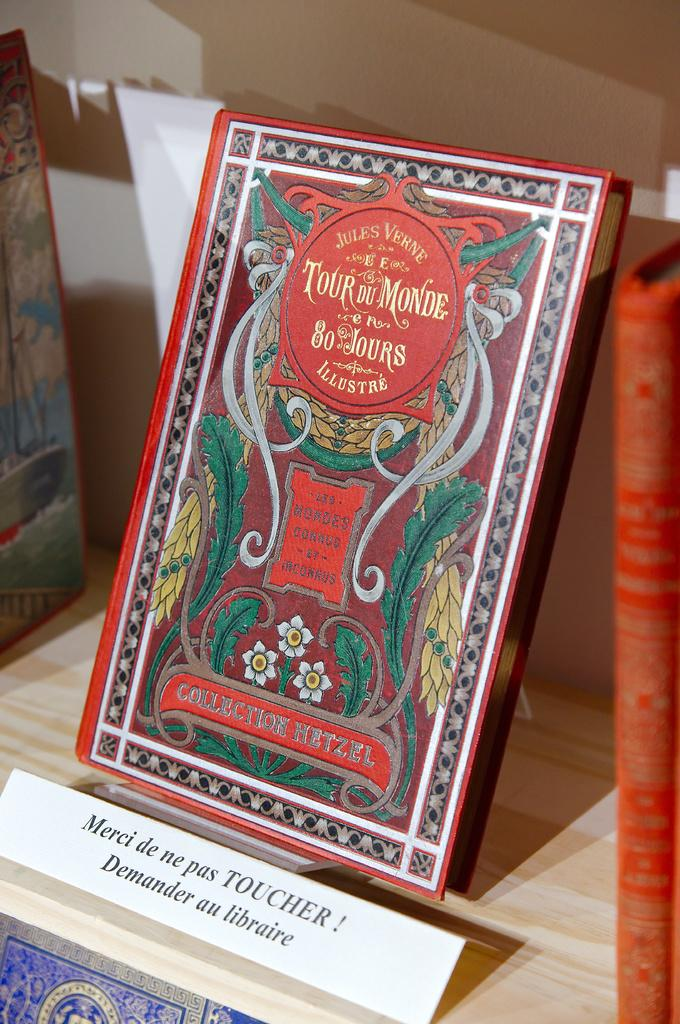<image>
Present a compact description of the photo's key features. A red book with green feathers on the cover is labeled as Collection Hetzel. 